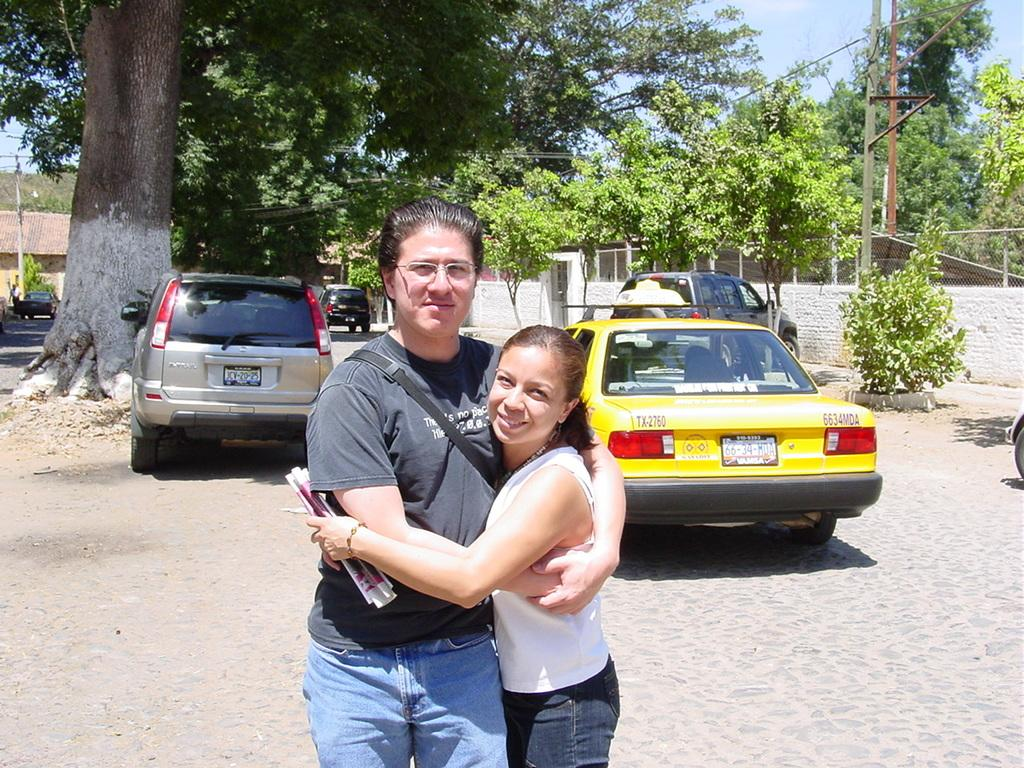<image>
Give a short and clear explanation of the subsequent image. a car that has the numbers 66 on them 